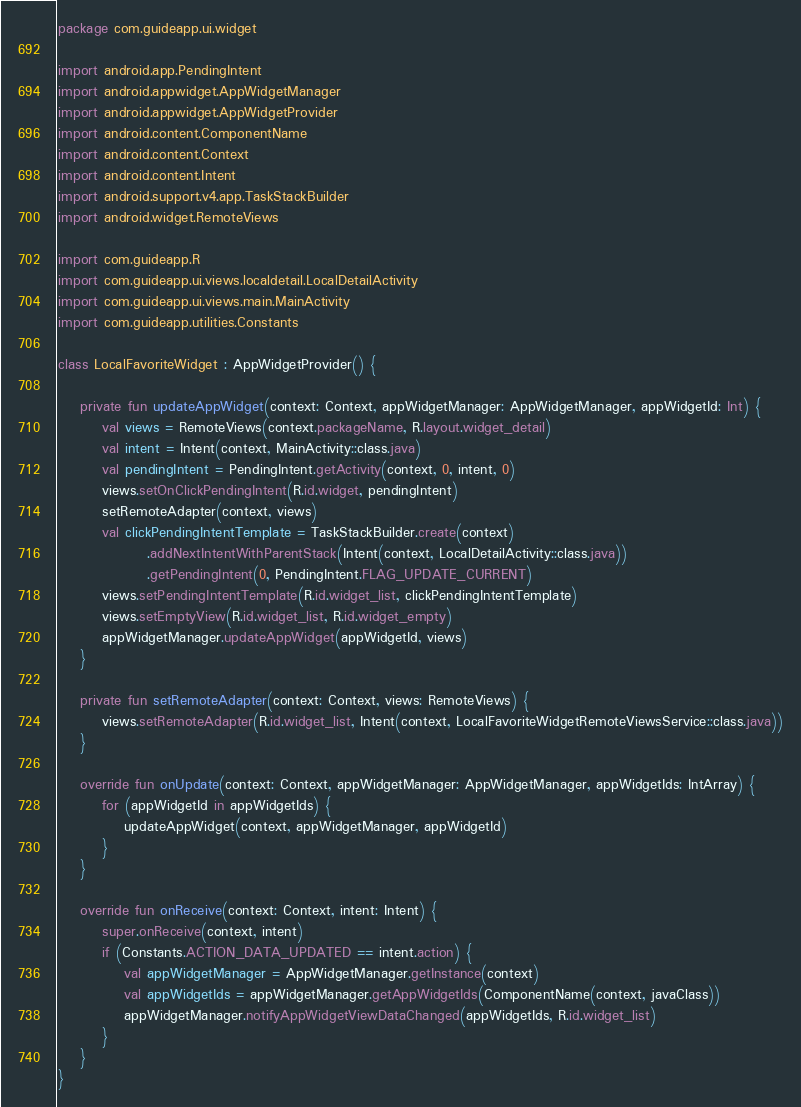Convert code to text. <code><loc_0><loc_0><loc_500><loc_500><_Kotlin_>package com.guideapp.ui.widget

import android.app.PendingIntent
import android.appwidget.AppWidgetManager
import android.appwidget.AppWidgetProvider
import android.content.ComponentName
import android.content.Context
import android.content.Intent
import android.support.v4.app.TaskStackBuilder
import android.widget.RemoteViews

import com.guideapp.R
import com.guideapp.ui.views.localdetail.LocalDetailActivity
import com.guideapp.ui.views.main.MainActivity
import com.guideapp.utilities.Constants

class LocalFavoriteWidget : AppWidgetProvider() {

    private fun updateAppWidget(context: Context, appWidgetManager: AppWidgetManager, appWidgetId: Int) {
        val views = RemoteViews(context.packageName, R.layout.widget_detail)
        val intent = Intent(context, MainActivity::class.java)
        val pendingIntent = PendingIntent.getActivity(context, 0, intent, 0)
        views.setOnClickPendingIntent(R.id.widget, pendingIntent)
        setRemoteAdapter(context, views)
        val clickPendingIntentTemplate = TaskStackBuilder.create(context)
                .addNextIntentWithParentStack(Intent(context, LocalDetailActivity::class.java))
                .getPendingIntent(0, PendingIntent.FLAG_UPDATE_CURRENT)
        views.setPendingIntentTemplate(R.id.widget_list, clickPendingIntentTemplate)
        views.setEmptyView(R.id.widget_list, R.id.widget_empty)
        appWidgetManager.updateAppWidget(appWidgetId, views)
    }

    private fun setRemoteAdapter(context: Context, views: RemoteViews) {
        views.setRemoteAdapter(R.id.widget_list, Intent(context, LocalFavoriteWidgetRemoteViewsService::class.java))
    }

    override fun onUpdate(context: Context, appWidgetManager: AppWidgetManager, appWidgetIds: IntArray) {
        for (appWidgetId in appWidgetIds) {
            updateAppWidget(context, appWidgetManager, appWidgetId)
        }
    }

    override fun onReceive(context: Context, intent: Intent) {
        super.onReceive(context, intent)
        if (Constants.ACTION_DATA_UPDATED == intent.action) {
            val appWidgetManager = AppWidgetManager.getInstance(context)
            val appWidgetIds = appWidgetManager.getAppWidgetIds(ComponentName(context, javaClass))
            appWidgetManager.notifyAppWidgetViewDataChanged(appWidgetIds, R.id.widget_list)
        }
    }
}

</code> 